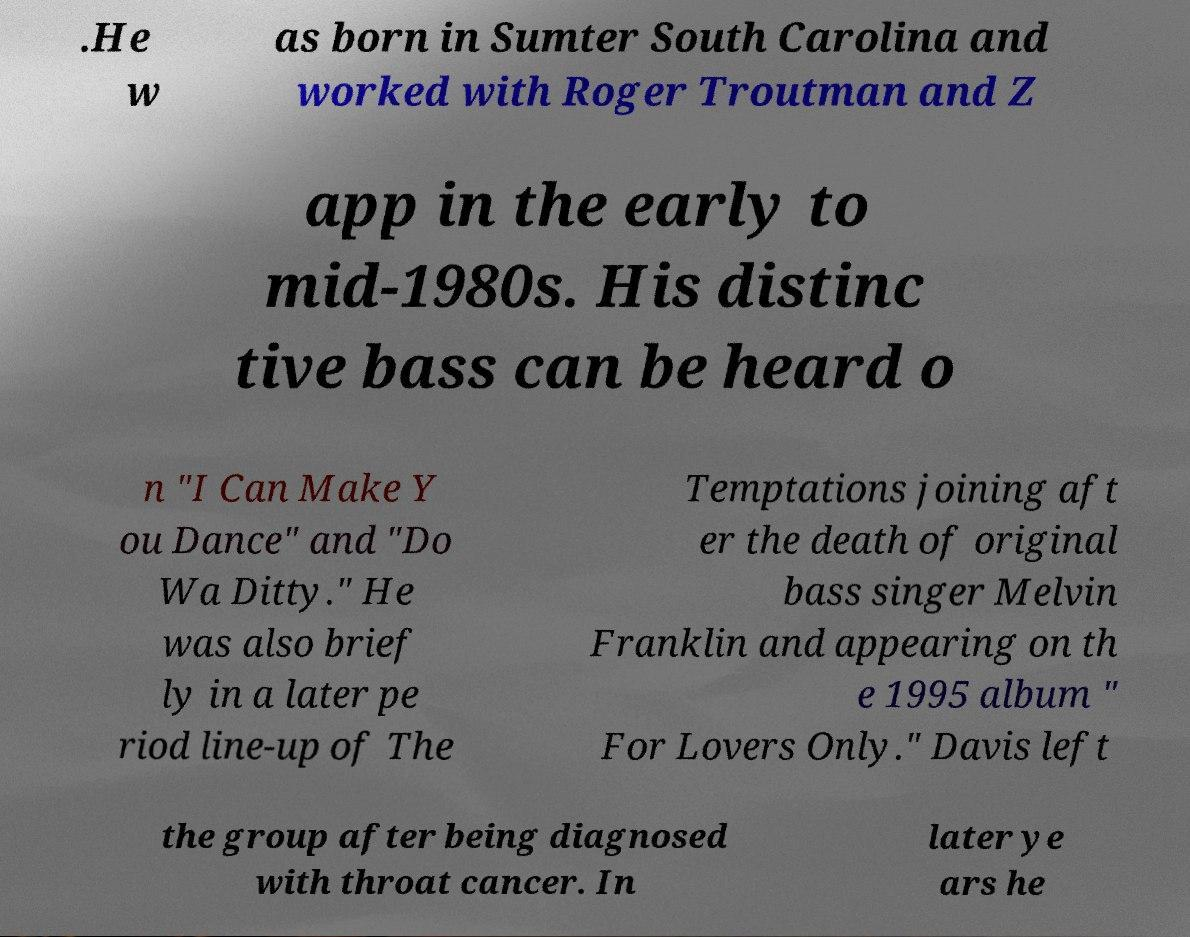Could you extract and type out the text from this image? .He w as born in Sumter South Carolina and worked with Roger Troutman and Z app in the early to mid-1980s. His distinc tive bass can be heard o n "I Can Make Y ou Dance" and "Do Wa Ditty." He was also brief ly in a later pe riod line-up of The Temptations joining aft er the death of original bass singer Melvin Franklin and appearing on th e 1995 album " For Lovers Only." Davis left the group after being diagnosed with throat cancer. In later ye ars he 